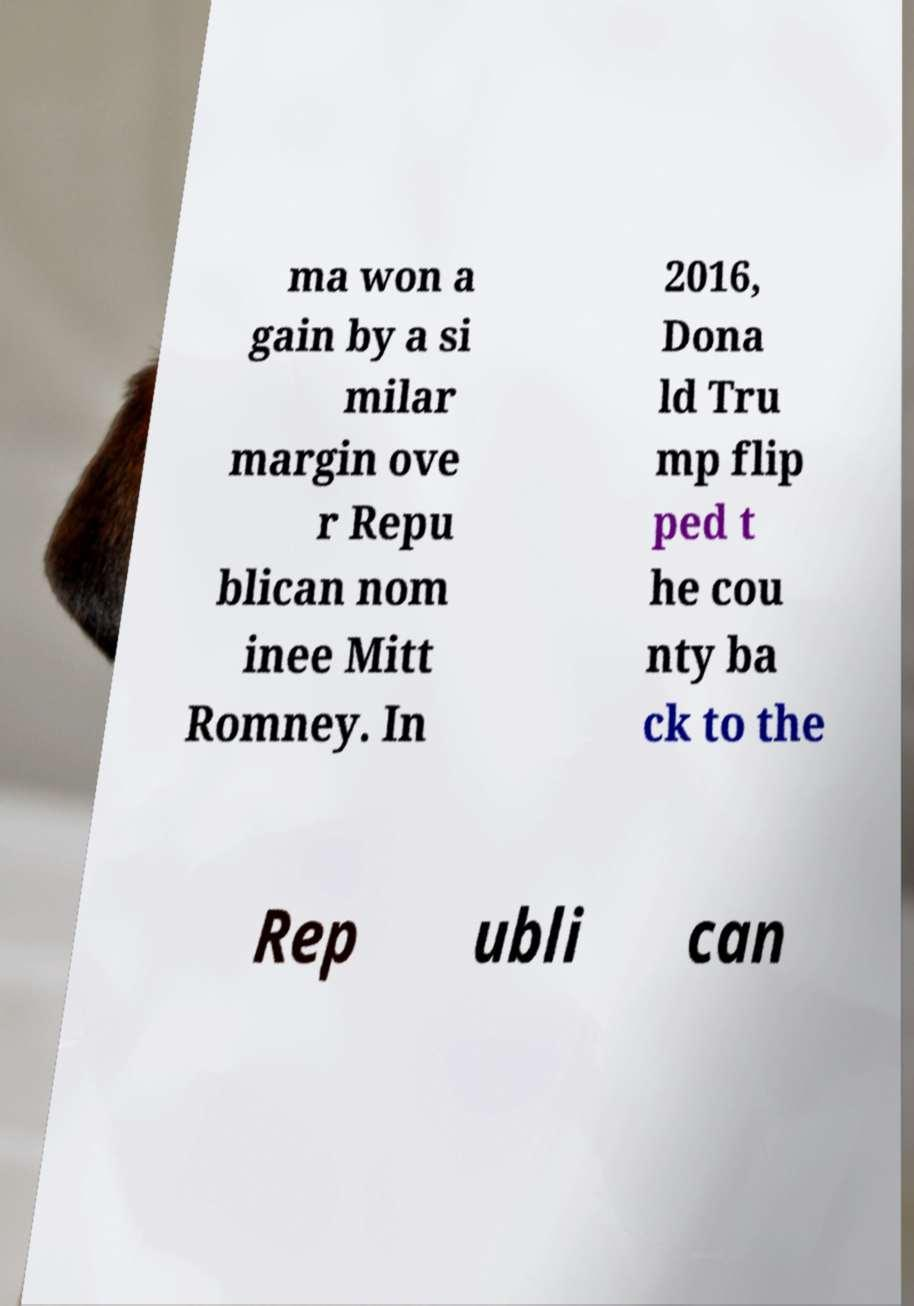Could you extract and type out the text from this image? ma won a gain by a si milar margin ove r Repu blican nom inee Mitt Romney. In 2016, Dona ld Tru mp flip ped t he cou nty ba ck to the Rep ubli can 